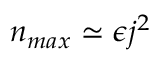Convert formula to latex. <formula><loc_0><loc_0><loc_500><loc_500>n _ { \max } \simeq \epsilon j ^ { 2 }</formula> 